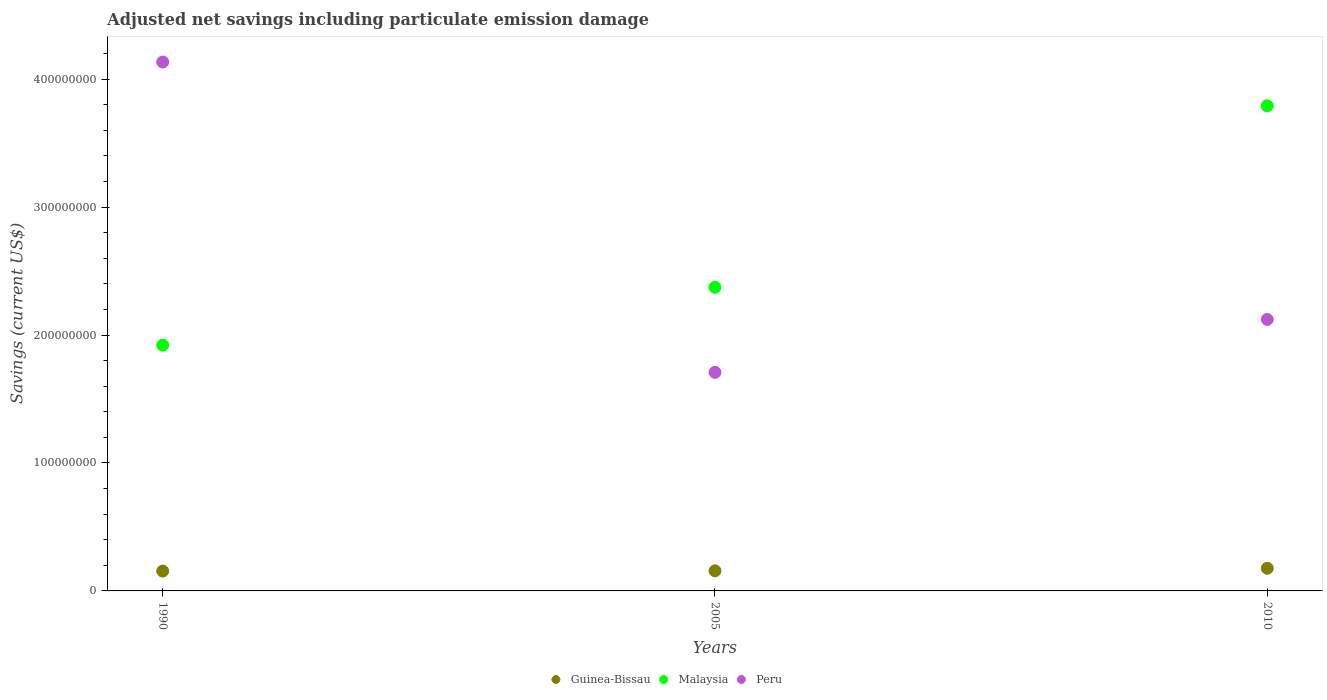Is the number of dotlines equal to the number of legend labels?
Your answer should be very brief. Yes. What is the net savings in Peru in 1990?
Ensure brevity in your answer.  4.13e+08. Across all years, what is the maximum net savings in Peru?
Provide a short and direct response. 4.13e+08. Across all years, what is the minimum net savings in Malaysia?
Your answer should be very brief. 1.92e+08. In which year was the net savings in Peru maximum?
Ensure brevity in your answer.  1990. What is the total net savings in Guinea-Bissau in the graph?
Your response must be concise. 4.89e+07. What is the difference between the net savings in Guinea-Bissau in 1990 and that in 2010?
Your answer should be very brief. -2.19e+06. What is the difference between the net savings in Malaysia in 2005 and the net savings in Guinea-Bissau in 2010?
Offer a terse response. 2.20e+08. What is the average net savings in Malaysia per year?
Provide a short and direct response. 2.70e+08. In the year 1990, what is the difference between the net savings in Peru and net savings in Malaysia?
Make the answer very short. 2.21e+08. In how many years, is the net savings in Peru greater than 400000000 US$?
Provide a succinct answer. 1. What is the ratio of the net savings in Guinea-Bissau in 2005 to that in 2010?
Offer a terse response. 0.89. Is the net savings in Malaysia in 1990 less than that in 2005?
Provide a short and direct response. Yes. What is the difference between the highest and the second highest net savings in Guinea-Bissau?
Make the answer very short. 1.97e+06. What is the difference between the highest and the lowest net savings in Guinea-Bissau?
Your answer should be compact. 2.19e+06. In how many years, is the net savings in Malaysia greater than the average net savings in Malaysia taken over all years?
Provide a short and direct response. 1. Is it the case that in every year, the sum of the net savings in Malaysia and net savings in Peru  is greater than the net savings in Guinea-Bissau?
Offer a very short reply. Yes. Does the net savings in Guinea-Bissau monotonically increase over the years?
Keep it short and to the point. Yes. Is the net savings in Malaysia strictly greater than the net savings in Peru over the years?
Keep it short and to the point. No. Does the graph contain any zero values?
Your answer should be very brief. No. Does the graph contain grids?
Make the answer very short. No. Where does the legend appear in the graph?
Give a very brief answer. Bottom center. How are the legend labels stacked?
Make the answer very short. Horizontal. What is the title of the graph?
Your answer should be compact. Adjusted net savings including particulate emission damage. What is the label or title of the X-axis?
Your answer should be compact. Years. What is the label or title of the Y-axis?
Your answer should be very brief. Savings (current US$). What is the Savings (current US$) of Guinea-Bissau in 1990?
Your answer should be compact. 1.55e+07. What is the Savings (current US$) of Malaysia in 1990?
Make the answer very short. 1.92e+08. What is the Savings (current US$) of Peru in 1990?
Offer a very short reply. 4.13e+08. What is the Savings (current US$) in Guinea-Bissau in 2005?
Your answer should be compact. 1.57e+07. What is the Savings (current US$) of Malaysia in 2005?
Offer a very short reply. 2.37e+08. What is the Savings (current US$) of Peru in 2005?
Keep it short and to the point. 1.71e+08. What is the Savings (current US$) in Guinea-Bissau in 2010?
Your answer should be compact. 1.77e+07. What is the Savings (current US$) of Malaysia in 2010?
Ensure brevity in your answer.  3.79e+08. What is the Savings (current US$) in Peru in 2010?
Make the answer very short. 2.12e+08. Across all years, what is the maximum Savings (current US$) of Guinea-Bissau?
Give a very brief answer. 1.77e+07. Across all years, what is the maximum Savings (current US$) in Malaysia?
Provide a short and direct response. 3.79e+08. Across all years, what is the maximum Savings (current US$) of Peru?
Provide a succinct answer. 4.13e+08. Across all years, what is the minimum Savings (current US$) in Guinea-Bissau?
Offer a very short reply. 1.55e+07. Across all years, what is the minimum Savings (current US$) of Malaysia?
Ensure brevity in your answer.  1.92e+08. Across all years, what is the minimum Savings (current US$) in Peru?
Offer a very short reply. 1.71e+08. What is the total Savings (current US$) of Guinea-Bissau in the graph?
Offer a terse response. 4.89e+07. What is the total Savings (current US$) in Malaysia in the graph?
Your response must be concise. 8.09e+08. What is the total Savings (current US$) in Peru in the graph?
Ensure brevity in your answer.  7.96e+08. What is the difference between the Savings (current US$) of Guinea-Bissau in 1990 and that in 2005?
Your answer should be very brief. -2.18e+05. What is the difference between the Savings (current US$) in Malaysia in 1990 and that in 2005?
Offer a very short reply. -4.52e+07. What is the difference between the Savings (current US$) of Peru in 1990 and that in 2005?
Your answer should be compact. 2.43e+08. What is the difference between the Savings (current US$) in Guinea-Bissau in 1990 and that in 2010?
Your response must be concise. -2.19e+06. What is the difference between the Savings (current US$) of Malaysia in 1990 and that in 2010?
Make the answer very short. -1.87e+08. What is the difference between the Savings (current US$) of Peru in 1990 and that in 2010?
Provide a succinct answer. 2.01e+08. What is the difference between the Savings (current US$) in Guinea-Bissau in 2005 and that in 2010?
Give a very brief answer. -1.97e+06. What is the difference between the Savings (current US$) in Malaysia in 2005 and that in 2010?
Make the answer very short. -1.42e+08. What is the difference between the Savings (current US$) of Peru in 2005 and that in 2010?
Your answer should be very brief. -4.13e+07. What is the difference between the Savings (current US$) in Guinea-Bissau in 1990 and the Savings (current US$) in Malaysia in 2005?
Ensure brevity in your answer.  -2.22e+08. What is the difference between the Savings (current US$) in Guinea-Bissau in 1990 and the Savings (current US$) in Peru in 2005?
Ensure brevity in your answer.  -1.55e+08. What is the difference between the Savings (current US$) of Malaysia in 1990 and the Savings (current US$) of Peru in 2005?
Offer a very short reply. 2.12e+07. What is the difference between the Savings (current US$) in Guinea-Bissau in 1990 and the Savings (current US$) in Malaysia in 2010?
Your answer should be compact. -3.64e+08. What is the difference between the Savings (current US$) in Guinea-Bissau in 1990 and the Savings (current US$) in Peru in 2010?
Keep it short and to the point. -1.97e+08. What is the difference between the Savings (current US$) in Malaysia in 1990 and the Savings (current US$) in Peru in 2010?
Give a very brief answer. -2.01e+07. What is the difference between the Savings (current US$) in Guinea-Bissau in 2005 and the Savings (current US$) in Malaysia in 2010?
Offer a very short reply. -3.63e+08. What is the difference between the Savings (current US$) in Guinea-Bissau in 2005 and the Savings (current US$) in Peru in 2010?
Your answer should be compact. -1.96e+08. What is the difference between the Savings (current US$) in Malaysia in 2005 and the Savings (current US$) in Peru in 2010?
Your answer should be compact. 2.51e+07. What is the average Savings (current US$) in Guinea-Bissau per year?
Your response must be concise. 1.63e+07. What is the average Savings (current US$) of Malaysia per year?
Make the answer very short. 2.70e+08. What is the average Savings (current US$) in Peru per year?
Provide a succinct answer. 2.65e+08. In the year 1990, what is the difference between the Savings (current US$) in Guinea-Bissau and Savings (current US$) in Malaysia?
Keep it short and to the point. -1.77e+08. In the year 1990, what is the difference between the Savings (current US$) of Guinea-Bissau and Savings (current US$) of Peru?
Provide a short and direct response. -3.98e+08. In the year 1990, what is the difference between the Savings (current US$) in Malaysia and Savings (current US$) in Peru?
Offer a very short reply. -2.21e+08. In the year 2005, what is the difference between the Savings (current US$) of Guinea-Bissau and Savings (current US$) of Malaysia?
Provide a short and direct response. -2.22e+08. In the year 2005, what is the difference between the Savings (current US$) of Guinea-Bissau and Savings (current US$) of Peru?
Your answer should be very brief. -1.55e+08. In the year 2005, what is the difference between the Savings (current US$) of Malaysia and Savings (current US$) of Peru?
Your answer should be compact. 6.65e+07. In the year 2010, what is the difference between the Savings (current US$) in Guinea-Bissau and Savings (current US$) in Malaysia?
Ensure brevity in your answer.  -3.61e+08. In the year 2010, what is the difference between the Savings (current US$) in Guinea-Bissau and Savings (current US$) in Peru?
Your answer should be very brief. -1.94e+08. In the year 2010, what is the difference between the Savings (current US$) of Malaysia and Savings (current US$) of Peru?
Provide a succinct answer. 1.67e+08. What is the ratio of the Savings (current US$) in Guinea-Bissau in 1990 to that in 2005?
Your answer should be very brief. 0.99. What is the ratio of the Savings (current US$) of Malaysia in 1990 to that in 2005?
Your answer should be very brief. 0.81. What is the ratio of the Savings (current US$) in Peru in 1990 to that in 2005?
Your answer should be compact. 2.42. What is the ratio of the Savings (current US$) of Guinea-Bissau in 1990 to that in 2010?
Keep it short and to the point. 0.88. What is the ratio of the Savings (current US$) of Malaysia in 1990 to that in 2010?
Offer a very short reply. 0.51. What is the ratio of the Savings (current US$) in Peru in 1990 to that in 2010?
Give a very brief answer. 1.95. What is the ratio of the Savings (current US$) in Guinea-Bissau in 2005 to that in 2010?
Offer a very short reply. 0.89. What is the ratio of the Savings (current US$) in Malaysia in 2005 to that in 2010?
Ensure brevity in your answer.  0.63. What is the ratio of the Savings (current US$) in Peru in 2005 to that in 2010?
Give a very brief answer. 0.81. What is the difference between the highest and the second highest Savings (current US$) in Guinea-Bissau?
Offer a terse response. 1.97e+06. What is the difference between the highest and the second highest Savings (current US$) in Malaysia?
Keep it short and to the point. 1.42e+08. What is the difference between the highest and the second highest Savings (current US$) in Peru?
Your answer should be very brief. 2.01e+08. What is the difference between the highest and the lowest Savings (current US$) in Guinea-Bissau?
Offer a terse response. 2.19e+06. What is the difference between the highest and the lowest Savings (current US$) of Malaysia?
Ensure brevity in your answer.  1.87e+08. What is the difference between the highest and the lowest Savings (current US$) in Peru?
Make the answer very short. 2.43e+08. 